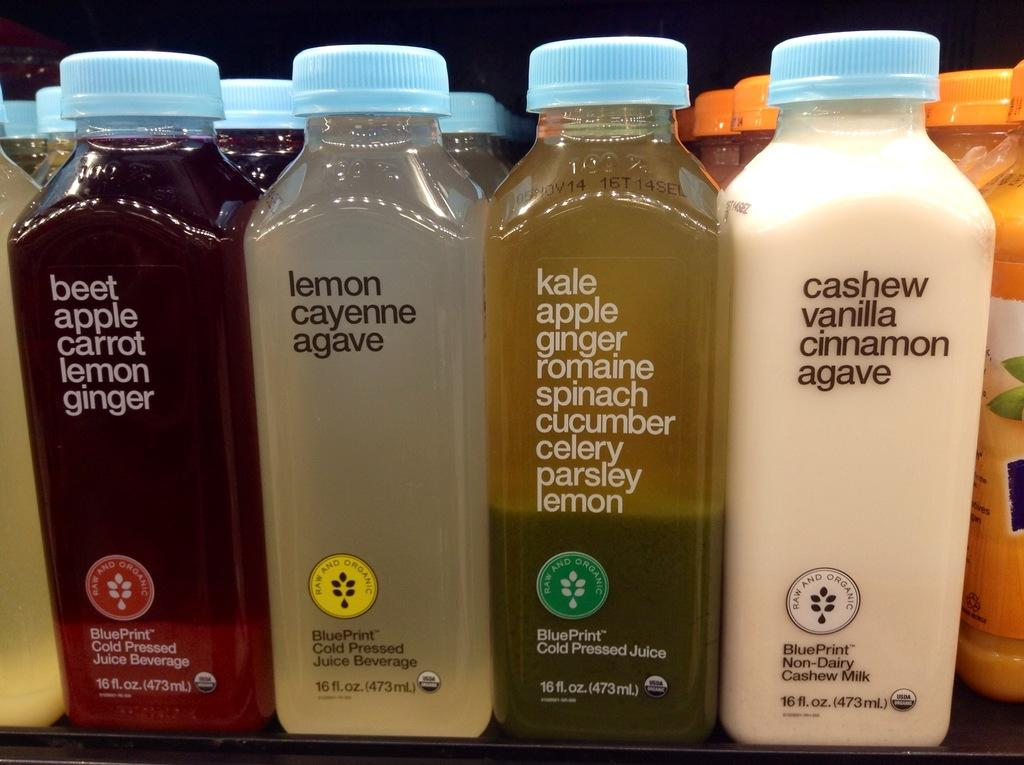<image>
Describe the image concisely. Several juices including beet apple carrot lemon ginger. 